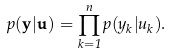<formula> <loc_0><loc_0><loc_500><loc_500>p ( \mathbf y | \mathbf u ) = \prod _ { k = 1 } ^ { n } p ( y _ { k } | u _ { k } ) .</formula> 